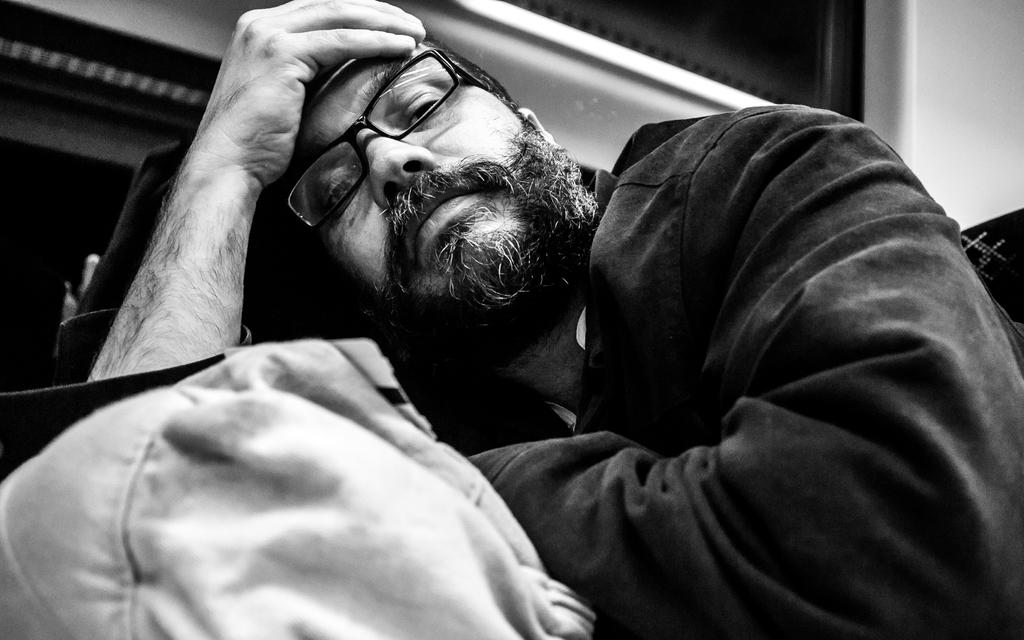Who is present in the image? There is a man in the image. What is the man wearing? The man is wearing spectacles. What is the man carrying? The man is carrying a bag. What can be seen in the background of the image? There is a wall in the background of the image. What type of knee surgery is the man undergoing in the image? There is no indication of a knee surgery or any medical procedure in the image; it simply shows a man wearing spectacles and carrying a bag. 